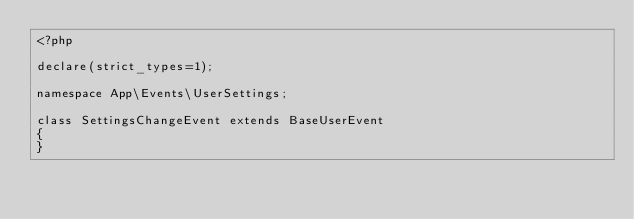<code> <loc_0><loc_0><loc_500><loc_500><_PHP_><?php

declare(strict_types=1);

namespace App\Events\UserSettings;

class SettingsChangeEvent extends BaseUserEvent
{
}
</code> 